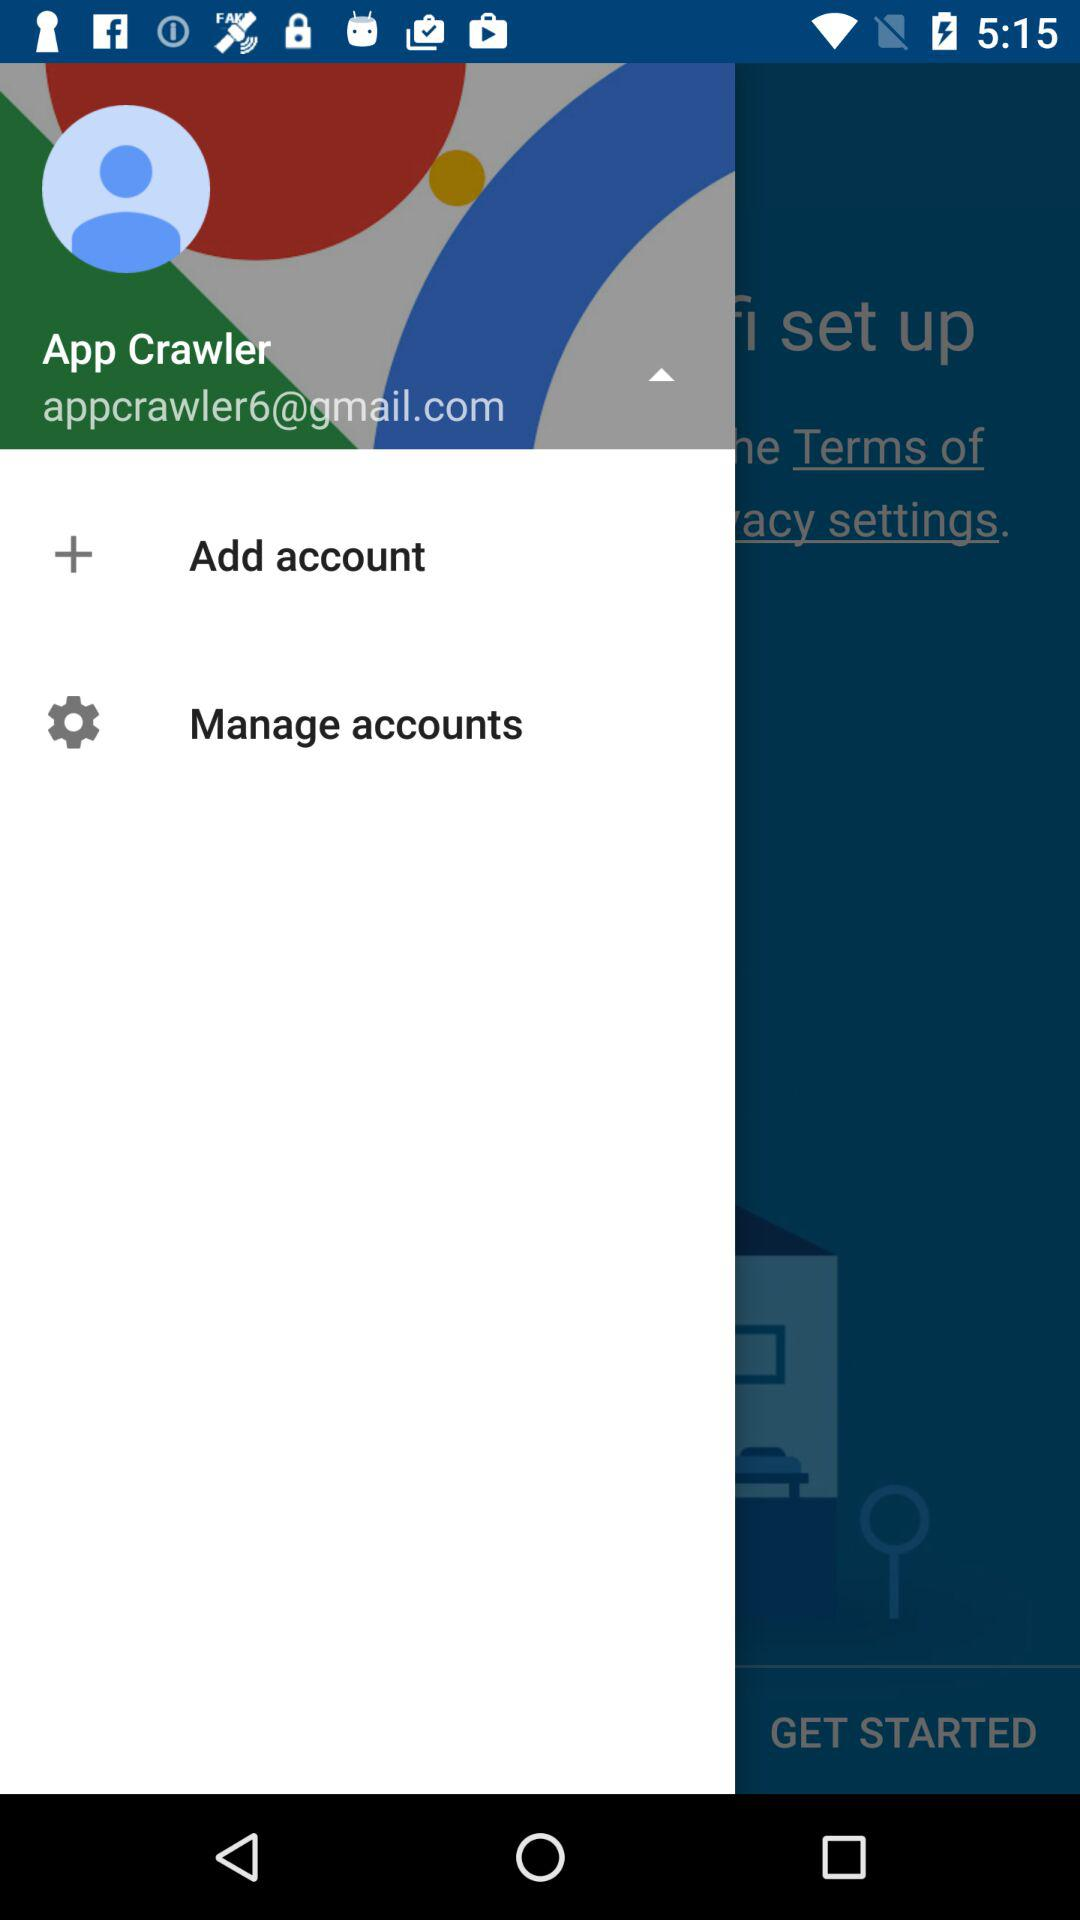What is the name of the user? The name of the user is "App Crawler". 